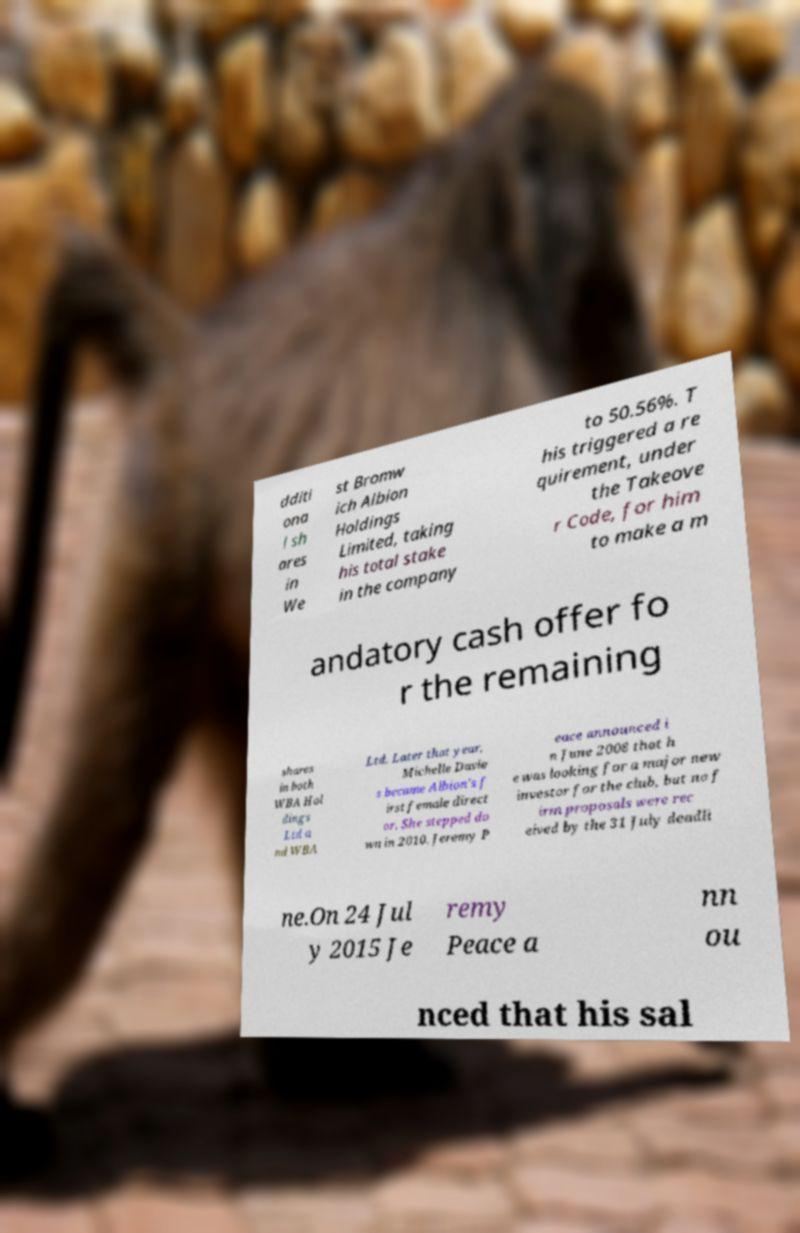For documentation purposes, I need the text within this image transcribed. Could you provide that? dditi ona l sh ares in We st Bromw ich Albion Holdings Limited, taking his total stake in the company to 50.56%. T his triggered a re quirement, under the Takeove r Code, for him to make a m andatory cash offer fo r the remaining shares in both WBA Hol dings Ltd a nd WBA Ltd. Later that year, Michelle Davie s became Albion's f irst female direct or. She stepped do wn in 2010. Jeremy P eace announced i n June 2008 that h e was looking for a major new investor for the club, but no f irm proposals were rec eived by the 31 July deadli ne.On 24 Jul y 2015 Je remy Peace a nn ou nced that his sal 